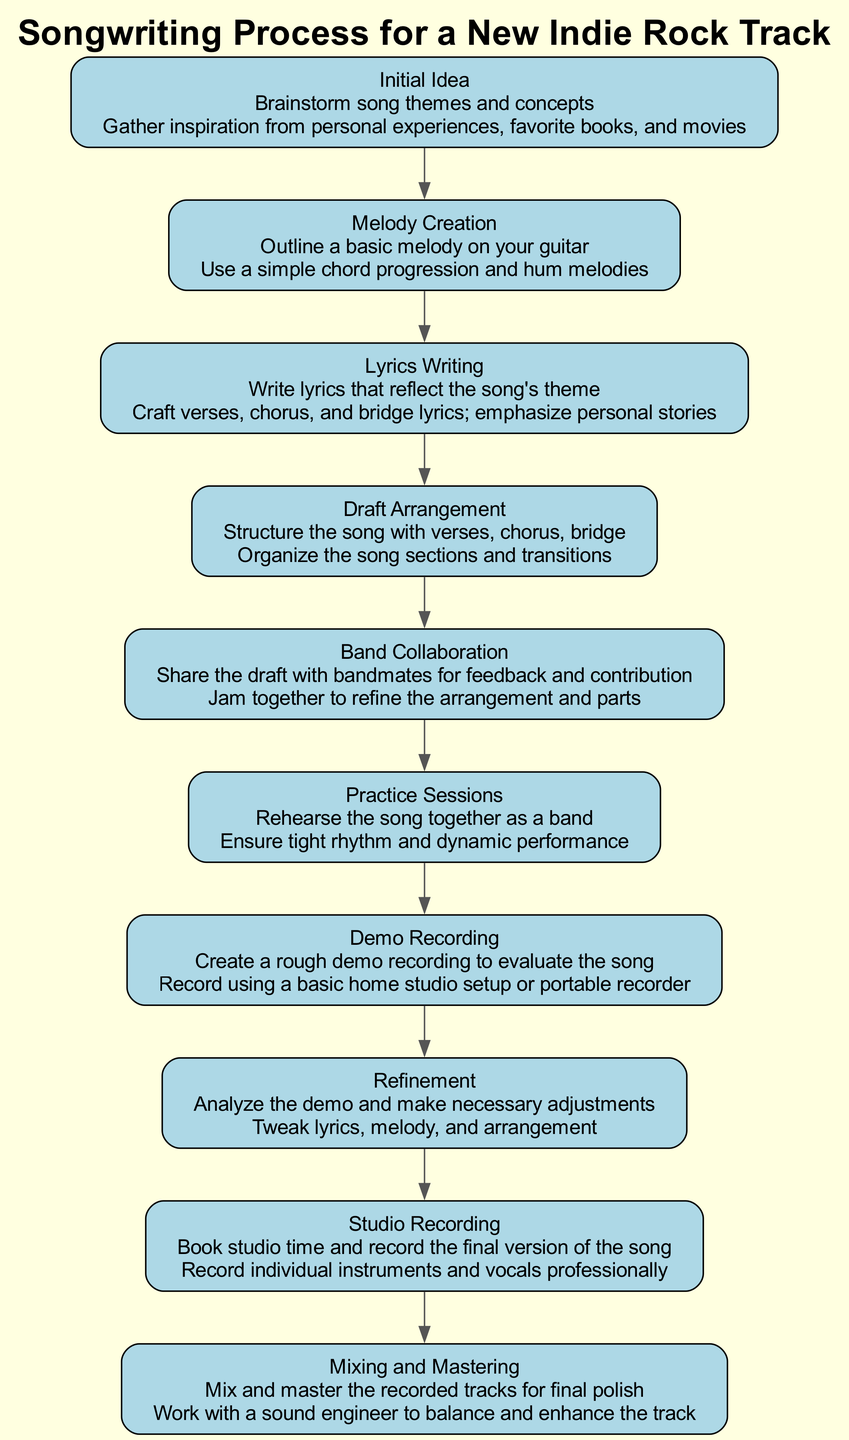What is the first step in the songwriting process? The first step is clearly labeled as "Initial Idea," where brainstorming of song themes and concepts occurs.
Answer: Initial Idea How many steps are there in the songwriting process? By counting the steps listed in the diagram, there are a total of ten steps from the initial idea to mixing and mastering.
Answer: 10 What follows after "Band Collaboration"? The next step after "Band Collaboration" is "Practice Sessions," where the band rehearses the song together.
Answer: Practice Sessions What action is taken during "Demo Recording"? During "Demo Recording," the action taken is to record using a basic home studio setup or portable recorder to evaluate the song.
Answer: Record using a basic home studio setup or portable recorder Which step emphasizes personal stories in its lyrics? The step that emphasizes personal stories is "Lyrics Writing," where verses, chorus, and bridge lyrics are crafted.
Answer: Lyrics Writing What is required before the "Studio Recording" step? Before the "Studio Recording" step, a "Demo Recording" must be completed to evaluate the song and make necessary adjustments.
Answer: Demo Recording How does "Refinement" contribute to the overall process? "Refinement" allows the songwriter to analyze the demo and make necessary adjustments, which is critical for enhancing lyrics, melody, and arrangement before finalizing the song.
Answer: Analyze the demo and make necessary adjustments What action is indicated for the step titled "Mixing and Mastering"? The action for the "Mixing and Mastering" step is to work with a sound engineer to balance and enhance the track.
Answer: Work with a sound engineer to balance and enhance the track What is the last step in the songwriting process? The last step in the process is labeled "Mixing and Mastering," which is where the recorded tracks get their final polish.
Answer: Mixing and Mastering 